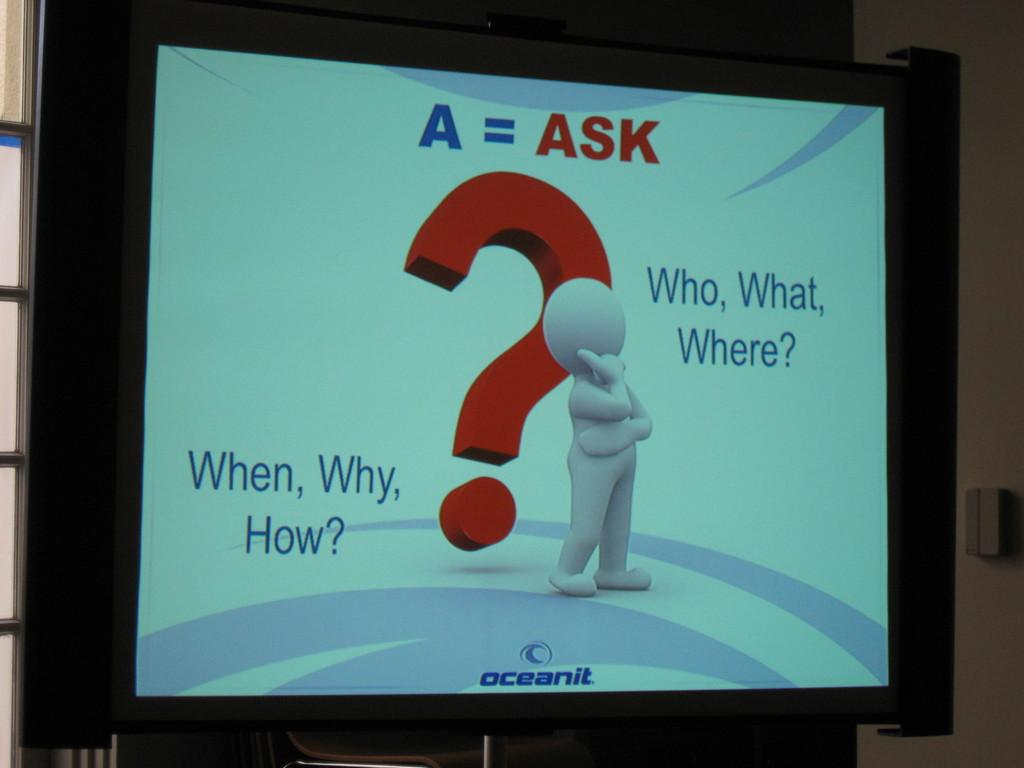<image>
Provide a brief description of the given image. The screen shows an animated figure with a large red question mark behind it and to the right, the words "Who, What, Where?" 